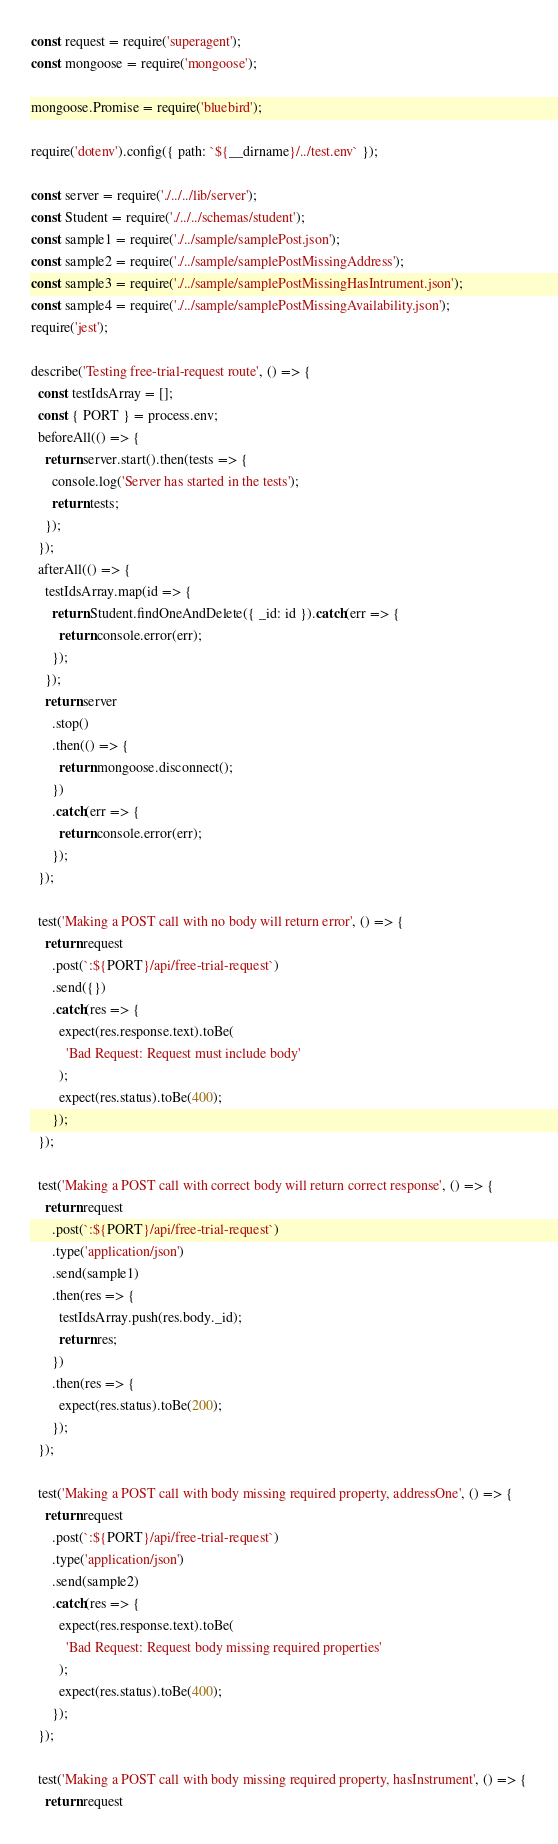Convert code to text. <code><loc_0><loc_0><loc_500><loc_500><_JavaScript_>const request = require('superagent');
const mongoose = require('mongoose');

mongoose.Promise = require('bluebird');

require('dotenv').config({ path: `${__dirname}/../test.env` });

const server = require('./../../lib/server');
const Student = require('./../../schemas/student');
const sample1 = require('./../sample/samplePost.json');
const sample2 = require('./../sample/samplePostMissingAddress');
const sample3 = require('./../sample/samplePostMissingHasIntrument.json');
const sample4 = require('./../sample/samplePostMissingAvailability.json');
require('jest');

describe('Testing free-trial-request route', () => {
  const testIdsArray = [];
  const { PORT } = process.env;
  beforeAll(() => {
    return server.start().then(tests => {
      console.log('Server has started in the tests');
      return tests;
    });
  });
  afterAll(() => {
    testIdsArray.map(id => {
      return Student.findOneAndDelete({ _id: id }).catch(err => {
        return console.error(err);
      });
    });
    return server
      .stop()
      .then(() => {
        return mongoose.disconnect();
      })
      .catch(err => {
        return console.error(err);
      });
  });

  test('Making a POST call with no body will return error', () => {
    return request
      .post(`:${PORT}/api/free-trial-request`)
      .send({})
      .catch(res => {
        expect(res.response.text).toBe(
          'Bad Request: Request must include body'
        );
        expect(res.status).toBe(400);
      });
  });

  test('Making a POST call with correct body will return correct response', () => {
    return request
      .post(`:${PORT}/api/free-trial-request`)
      .type('application/json')
      .send(sample1)
      .then(res => {
        testIdsArray.push(res.body._id);
        return res;
      })
      .then(res => {
        expect(res.status).toBe(200);
      });
  });

  test('Making a POST call with body missing required property, addressOne', () => {
    return request
      .post(`:${PORT}/api/free-trial-request`)
      .type('application/json')
      .send(sample2)
      .catch(res => {
        expect(res.response.text).toBe(
          'Bad Request: Request body missing required properties'
        );
        expect(res.status).toBe(400);
      });
  });

  test('Making a POST call with body missing required property, hasInstrument', () => {
    return request</code> 